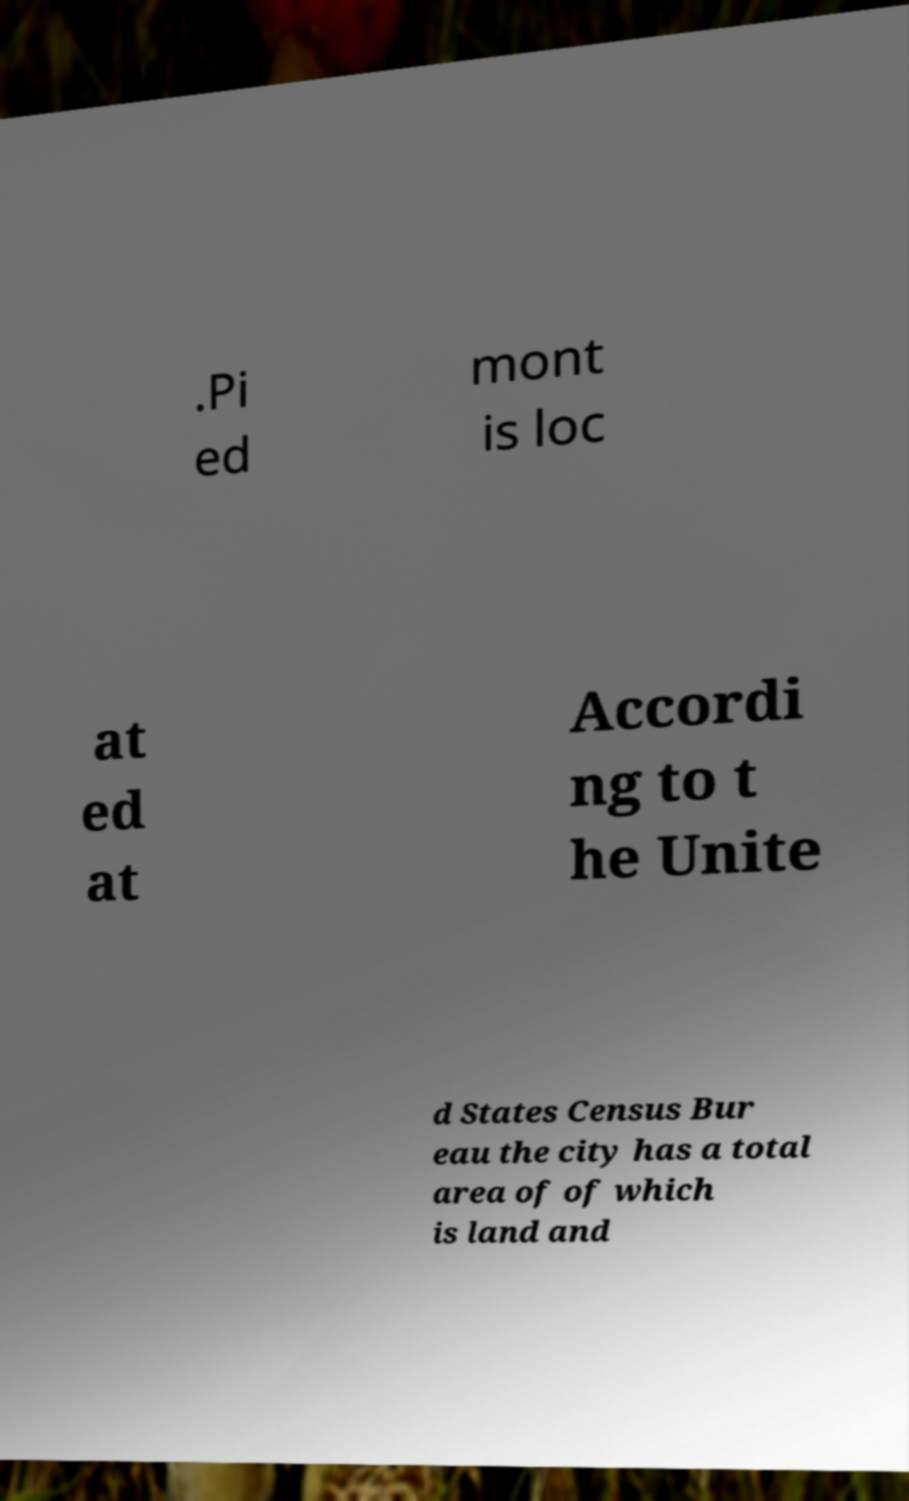Can you read and provide the text displayed in the image?This photo seems to have some interesting text. Can you extract and type it out for me? .Pi ed mont is loc at ed at Accordi ng to t he Unite d States Census Bur eau the city has a total area of of which is land and 